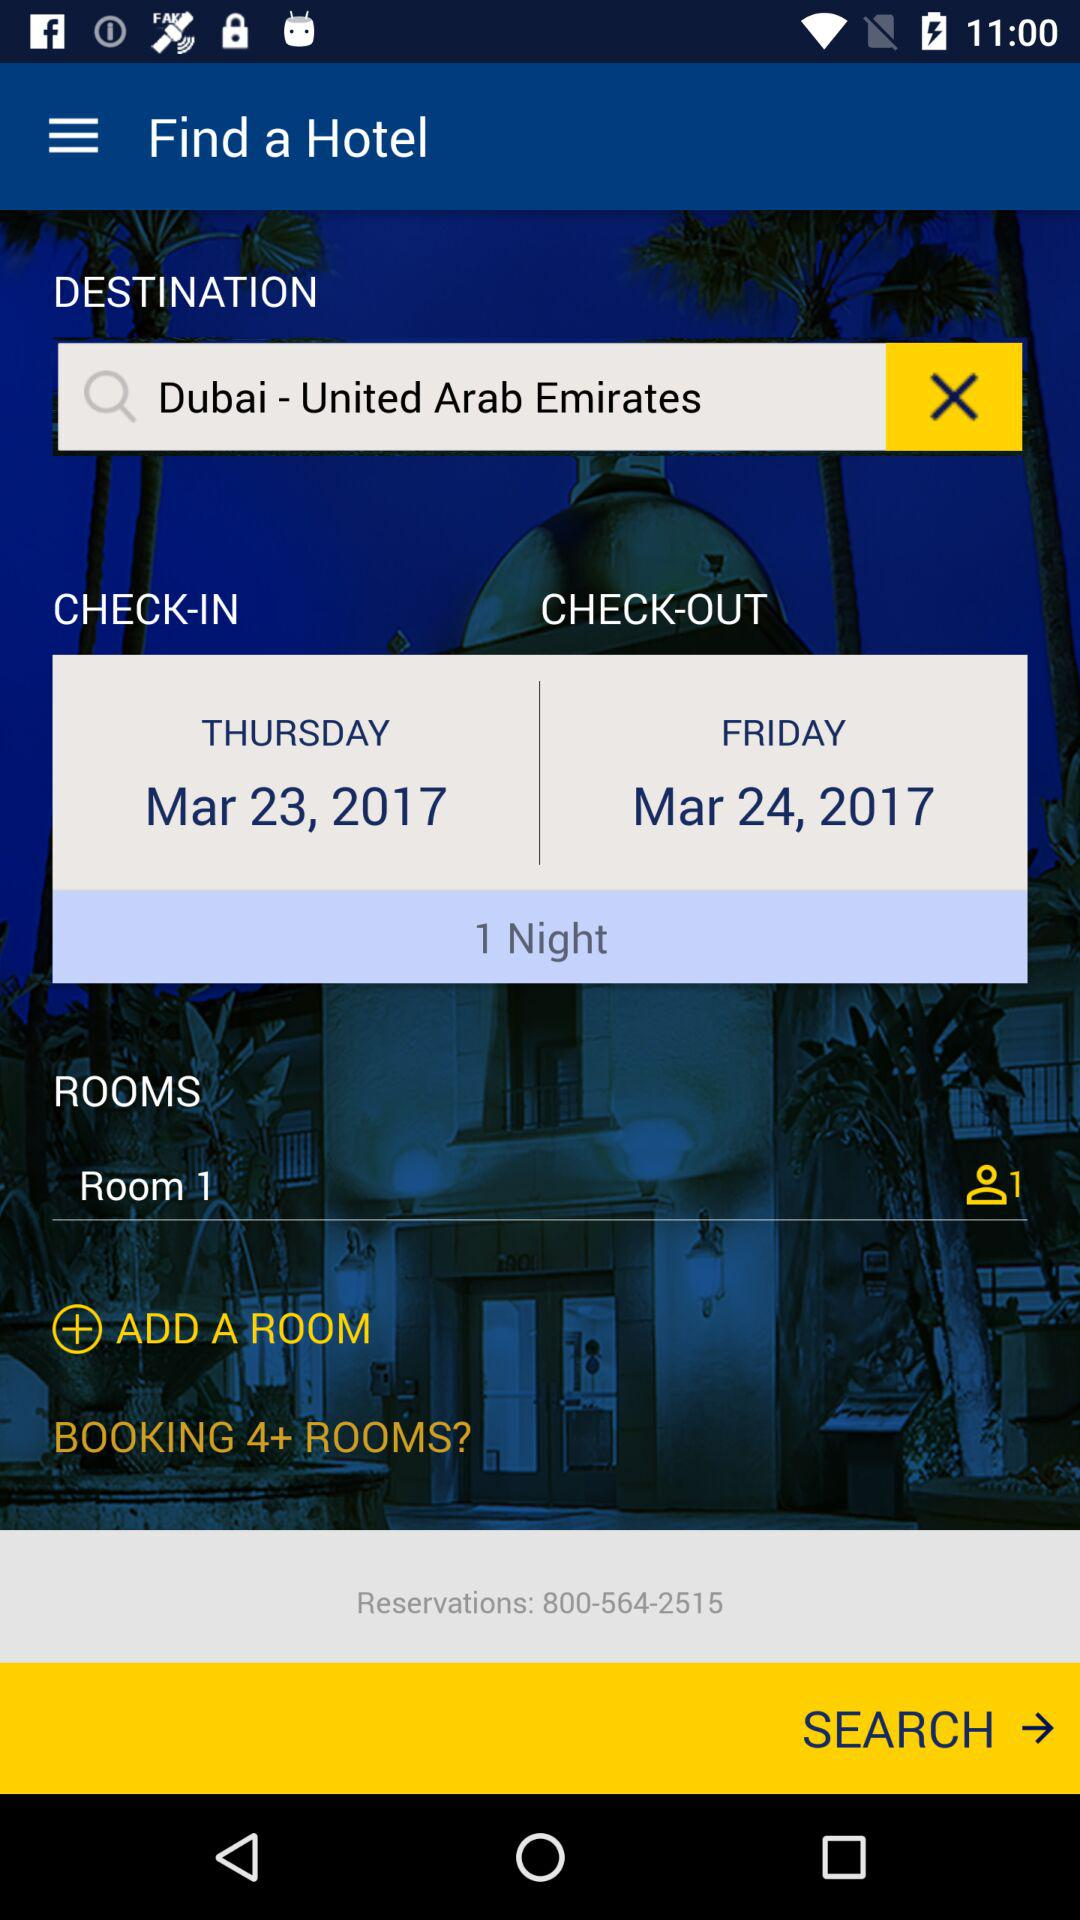How many rooms are currently booked?
Answer the question using a single word or phrase. 1 